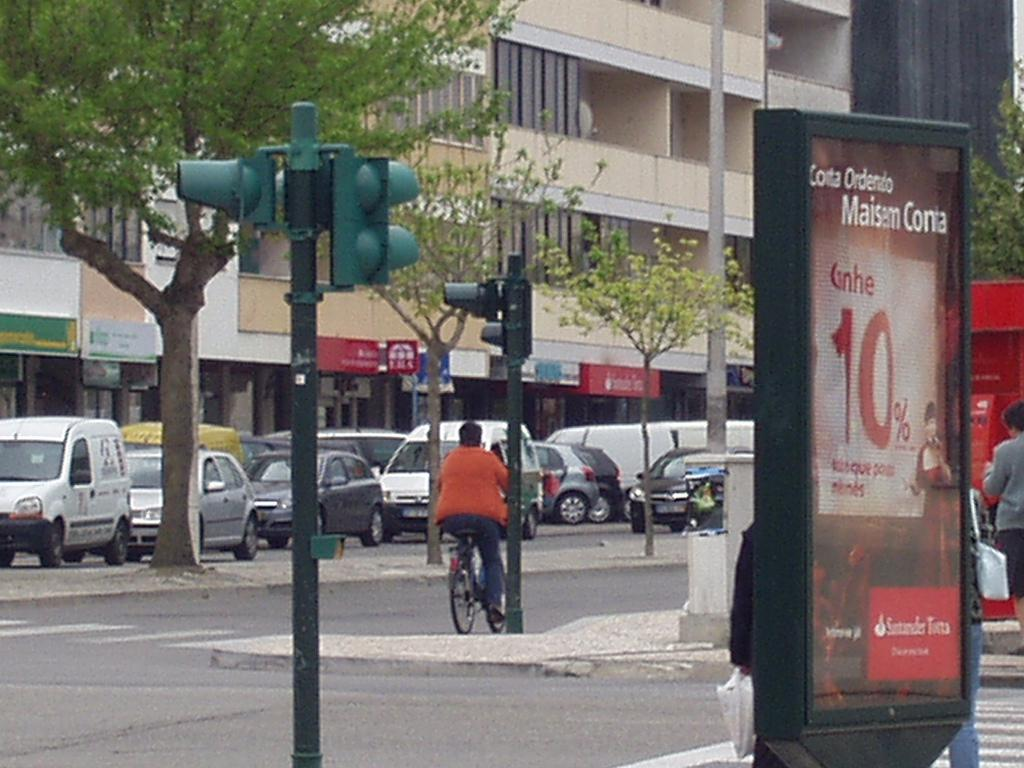Question: what has big and red 10% text on it?
Choices:
A. Sale paper.
B. Billboard.
C. Ad sign.
D. Coupon.
Answer with the letter. Answer: C Question: what color is the bike rider's shirt?
Choices:
A. Blue.
B. Red.
C. Purple.
D. Orange.
Answer with the letter. Answer: D Question: who is on a bike?
Choices:
A. A person in orange.
B. Two men.
C. A lady.
D. A little kid.
Answer with the letter. Answer: A Question: what does the street view include?
Choices:
A. Cars parked, stop lights and a building.
B. Skyscrapers.
C. Pedestrians on the sidewalk.
D. A farmer's market.
Answer with the letter. Answer: A Question: where is the photo taken?
Choices:
A. The hotel.
B. The motel.
C. The school.
D. On a street.
Answer with the letter. Answer: D Question: why is it bright out?
Choices:
A. The sun is above.
B. It's during the day.
C. It's morning.
D. The lights are shining down.
Answer with the letter. Answer: B Question: where are the cars?
Choices:
A. Parked in the driveway.
B. Stopped in the road.
C. Parked on the grass.
D. Stopped on the bridge.
Answer with the letter. Answer: B Question: what are planted in the median?
Choices:
A. Trees.
B. Flowers.
C. Plants.
D. Bushes.
Answer with the letter. Answer: A Question: what is the man in the orange coat doing?
Choices:
A. Working.
B. Riding a bicycle.
C. Sleeping.
D. Watching tv.
Answer with the letter. Answer: B Question: how many people are almost totally covered by an advertisement?
Choices:
A. One.
B. Three.
C. Two.
D. Four.
Answer with the letter. Answer: C Question: who rides a bike down the street?
Choices:
A. A man.
B. A woman.
C. A child.
D. A person.
Answer with the letter. Answer: D Question: what is daytime?
Choices:
A. The photo.
B. The drawing.
C. The image on the monitor.
D. The message on the board.
Answer with the letter. Answer: A Question: what is the Person doing?
Choices:
A. Reading a bible.
B. Jogging.
C. Riding a Bike.
D. Taking a nap.
Answer with the letter. Answer: C Question: where are the cars parked?
Choices:
A. Next to the sidewalk.
B. In the parking lot.
C. Around the corner.
D. Down the street.
Answer with the letter. Answer: A Question: why are there lines on the street?
Choices:
A. To separate traffic.
B. To mark parking spaces.
C. It is a crosswalk.
D. To show passing lane.
Answer with the letter. Answer: C 